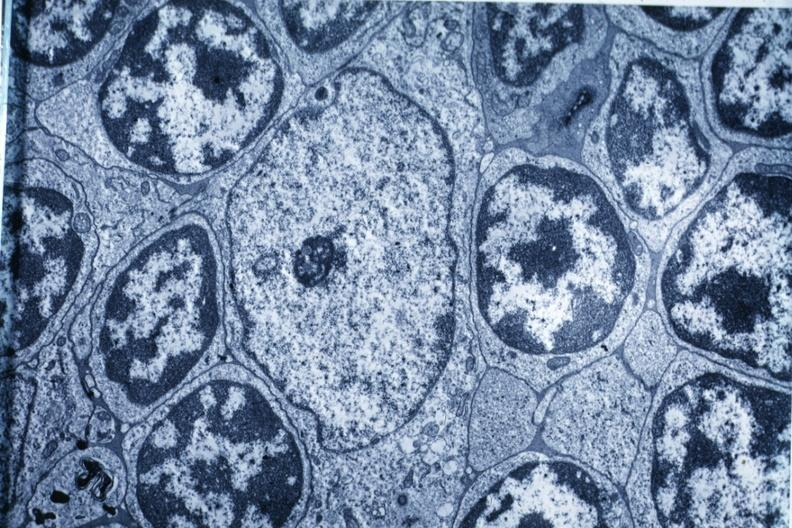s fracture present?
Answer the question using a single word or phrase. No 